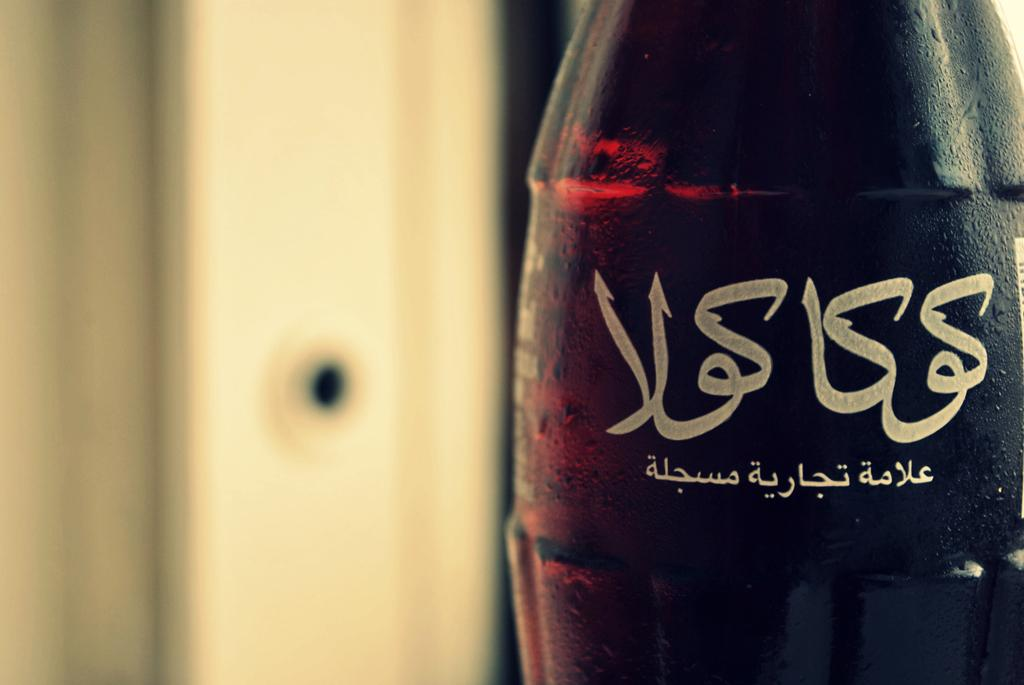What object can be seen in the image? There is a bottle in the image. What language is written on the bottle? The bottle has Urdu text on it. What musical instrument is being played in the image? There is no musical instrument being played in the image; it only features a bottle with Urdu text on it. 